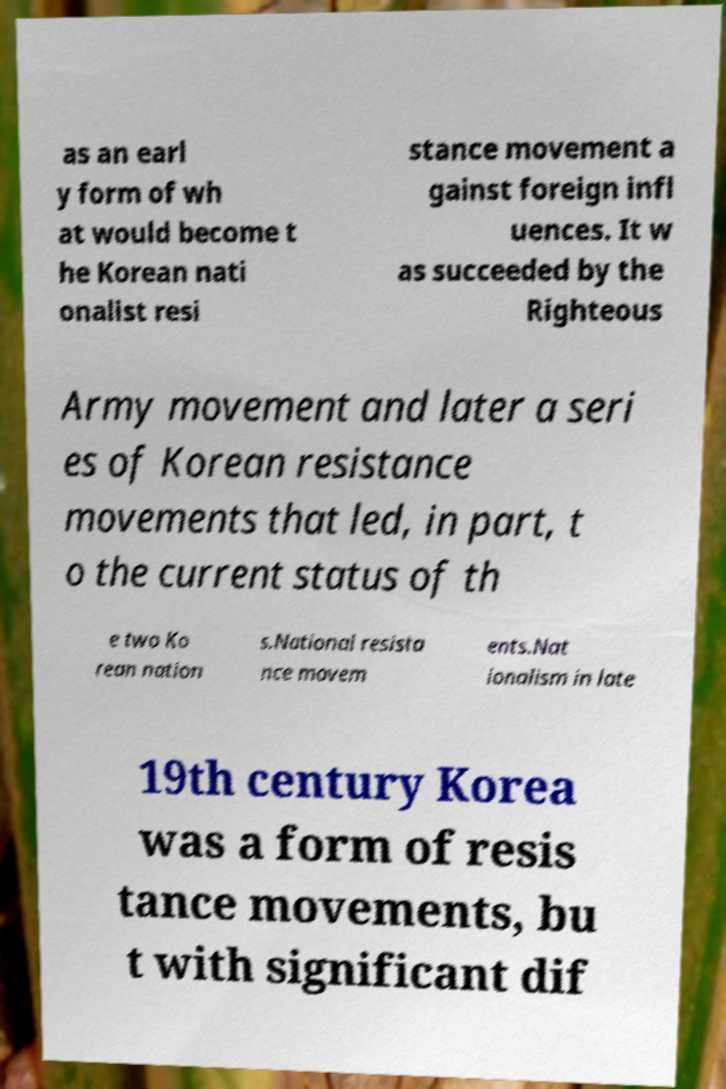Please identify and transcribe the text found in this image. as an earl y form of wh at would become t he Korean nati onalist resi stance movement a gainst foreign infl uences. It w as succeeded by the Righteous Army movement and later a seri es of Korean resistance movements that led, in part, t o the current status of th e two Ko rean nation s.National resista nce movem ents.Nat ionalism in late 19th century Korea was a form of resis tance movements, bu t with significant dif 